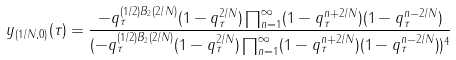Convert formula to latex. <formula><loc_0><loc_0><loc_500><loc_500>y _ { ( 1 / N , 0 ) } ( \tau ) = \frac { - q _ { \tau } ^ { ( 1 / 2 ) B _ { 2 } ( 2 / N ) } ( 1 - q _ { \tau } ^ { 2 / N } ) \prod _ { n = 1 } ^ { \infty } ( 1 - q _ { \tau } ^ { n + 2 / N } ) ( 1 - q _ { \tau } ^ { n - 2 / N } ) } { ( { - q _ { \tau } ^ { ( 1 / 2 ) B _ { 2 } ( 2 / N ) } ( 1 - q _ { \tau } ^ { 2 / N } ) \prod _ { n = 1 } ^ { \infty } ( 1 - q _ { \tau } ^ { n + 2 / N } ) ( 1 - q _ { \tau } ^ { n - 2 / N } ) } ) ^ { 4 } }</formula> 